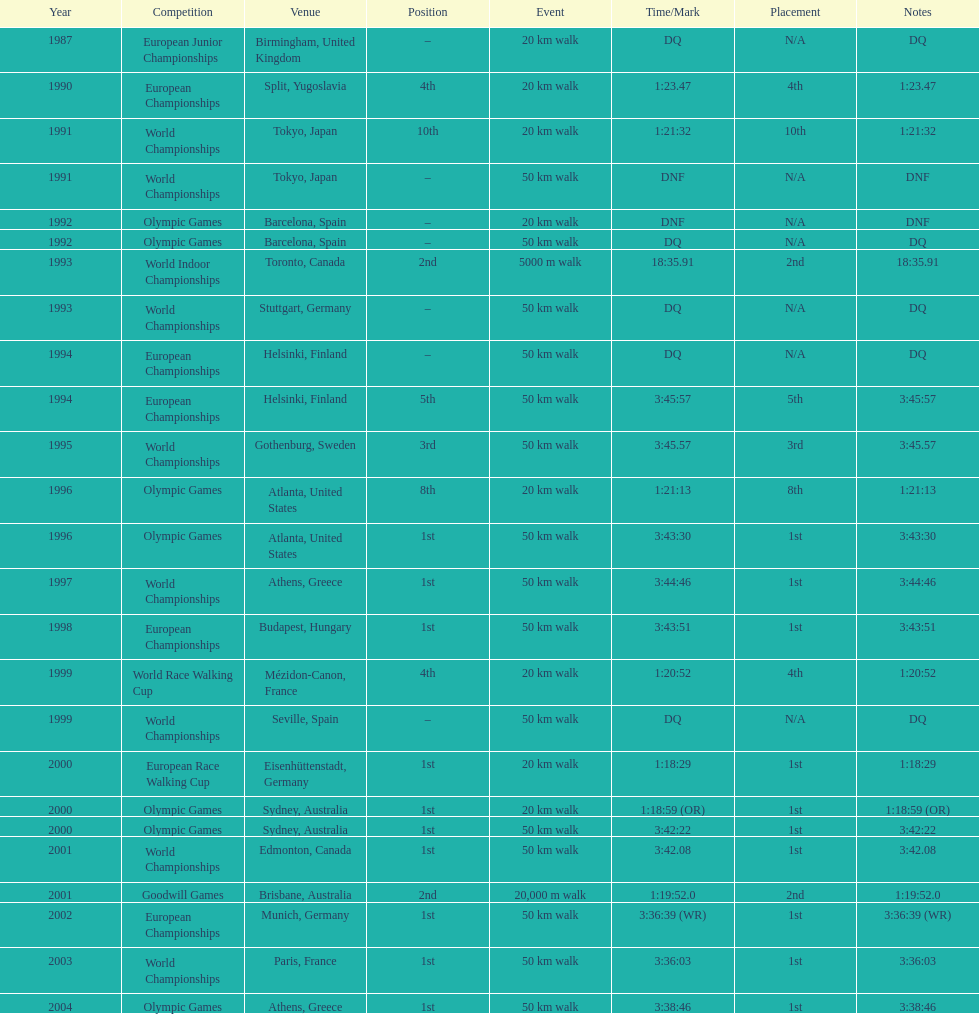How many times did korzeniowski finish above fourth place? 13. 